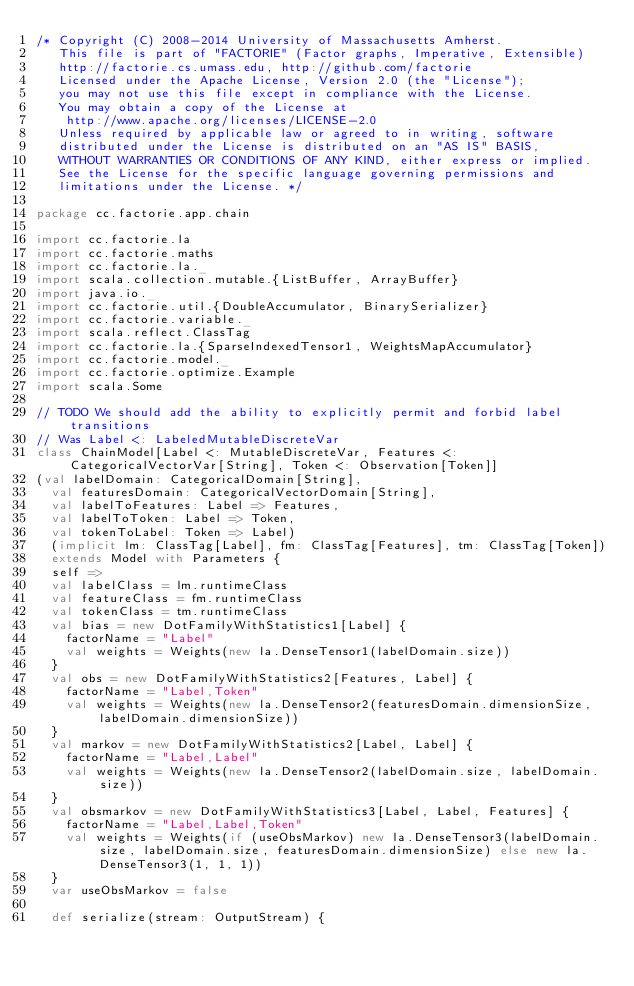<code> <loc_0><loc_0><loc_500><loc_500><_Scala_>/* Copyright (C) 2008-2014 University of Massachusetts Amherst.
   This file is part of "FACTORIE" (Factor graphs, Imperative, Extensible)
   http://factorie.cs.umass.edu, http://github.com/factorie
   Licensed under the Apache License, Version 2.0 (the "License");
   you may not use this file except in compliance with the License.
   You may obtain a copy of the License at
    http://www.apache.org/licenses/LICENSE-2.0
   Unless required by applicable law or agreed to in writing, software
   distributed under the License is distributed on an "AS IS" BASIS,
   WITHOUT WARRANTIES OR CONDITIONS OF ANY KIND, either express or implied.
   See the License for the specific language governing permissions and
   limitations under the License. */

package cc.factorie.app.chain

import cc.factorie.la
import cc.factorie.maths
import cc.factorie.la._
import scala.collection.mutable.{ListBuffer, ArrayBuffer}
import java.io._
import cc.factorie.util.{DoubleAccumulator, BinarySerializer}
import cc.factorie.variable._
import scala.reflect.ClassTag
import cc.factorie.la.{SparseIndexedTensor1, WeightsMapAccumulator}
import cc.factorie.model._
import cc.factorie.optimize.Example
import scala.Some

// TODO We should add the ability to explicitly permit and forbid label transitions
// Was Label <: LabeledMutableDiscreteVar
class ChainModel[Label <: MutableDiscreteVar, Features <: CategoricalVectorVar[String], Token <: Observation[Token]]
(val labelDomain: CategoricalDomain[String],
  val featuresDomain: CategoricalVectorDomain[String],
  val labelToFeatures: Label => Features,
  val labelToToken: Label => Token,
  val tokenToLabel: Token => Label)
  (implicit lm: ClassTag[Label], fm: ClassTag[Features], tm: ClassTag[Token])
  extends Model with Parameters {
  self =>
  val labelClass = lm.runtimeClass
  val featureClass = fm.runtimeClass
  val tokenClass = tm.runtimeClass
  val bias = new DotFamilyWithStatistics1[Label] {
    factorName = "Label"
    val weights = Weights(new la.DenseTensor1(labelDomain.size))
  }
  val obs = new DotFamilyWithStatistics2[Features, Label] {
    factorName = "Label,Token"
    val weights = Weights(new la.DenseTensor2(featuresDomain.dimensionSize, labelDomain.dimensionSize))
  }
  val markov = new DotFamilyWithStatistics2[Label, Label] {
    factorName = "Label,Label"
    val weights = Weights(new la.DenseTensor2(labelDomain.size, labelDomain.size))
  }
  val obsmarkov = new DotFamilyWithStatistics3[Label, Label, Features] {
    factorName = "Label,Label,Token"
    val weights = Weights(if (useObsMarkov) new la.DenseTensor3(labelDomain.size, labelDomain.size, featuresDomain.dimensionSize) else new la.DenseTensor3(1, 1, 1))
  }
  var useObsMarkov = false

  def serialize(stream: OutputStream) {</code> 